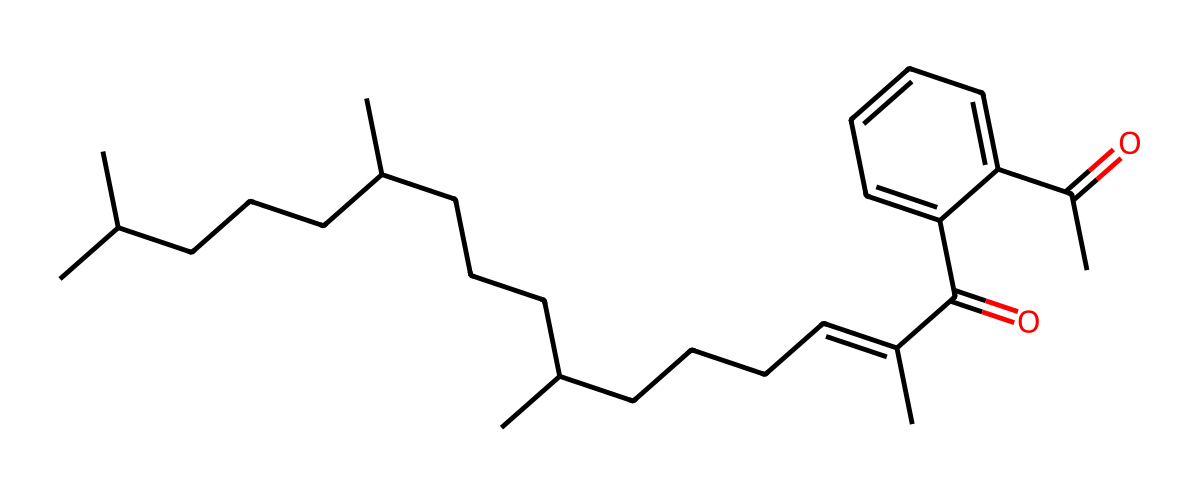What is the main functional group in this vitamin K structure? The structure contains a carbonyl group (-C=O) and a double bond, which indicates the presence of a ketone functional group as part of its structure.
Answer: ketone How many rings are present in this molecular structure? Analyzing the structure, there are no cyclic components noted; all carbon atoms are part of linear or branched chains.
Answer: 0 What is the total number of carbon atoms in this molecule? By counting all the carbon symbols in the SMILES representation, there are 38 carbon atoms present.
Answer: 38 Does this vitamin K structure include any nitrogen atoms? By reviewing the structure, there are no nitrogen atoms indicated in the SMILES representation, confirming its absence.
Answer: no What type of vitamin is represented by this molecular structure? Comparing common vitamin structures, this molecule represents vitamin K, specifically vitamin K1 (phylloquinone), known for its role in coagulation.
Answer: vitamin K How many double bonds are present in this vitamin K structure? By examining the SMILES notation, there is one double bond between two carbon atoms indicated by the 'C=C' notation, reflecting an alkene feature.
Answer: 1 What distinctive feature of vitamin K is presented in its structure? Vitamin K is characterized by its long aliphatic side chains and the presence of a naphthoquinone moiety, aiding in its biological function related to blood clotting.
Answer: naphthoquinone 